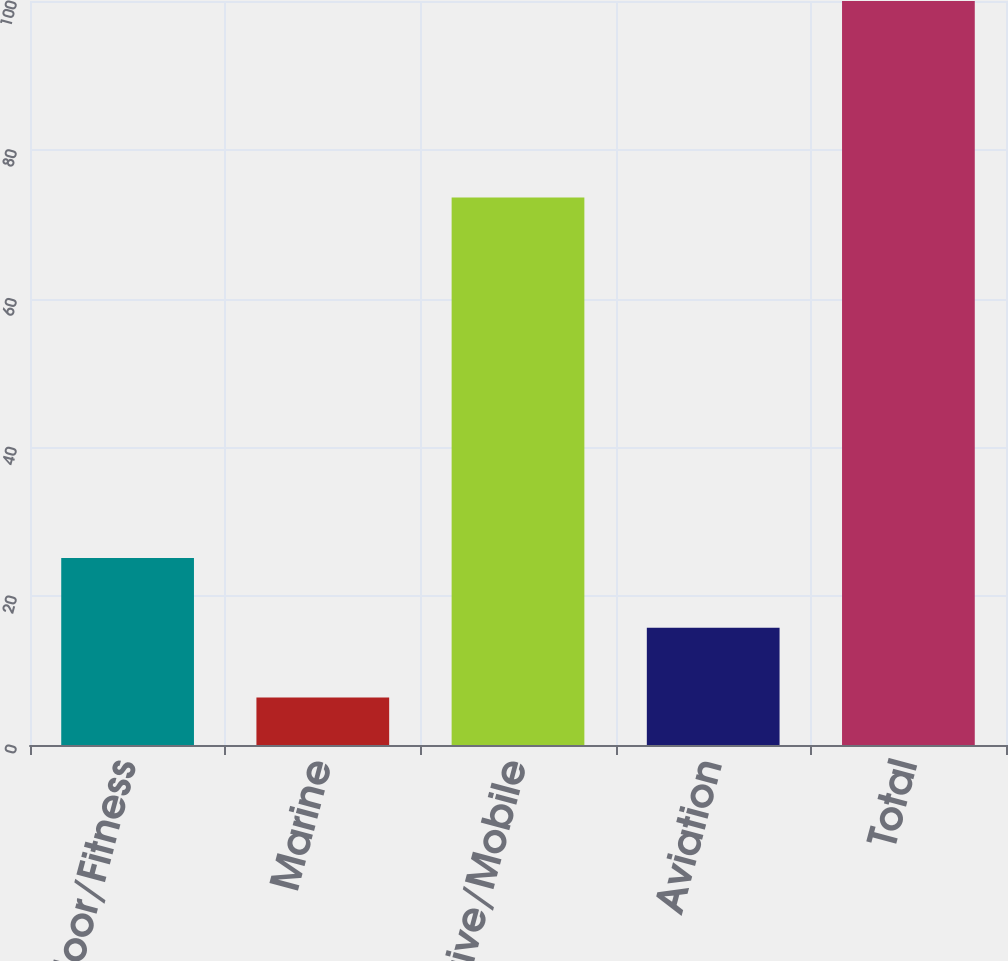Convert chart to OTSL. <chart><loc_0><loc_0><loc_500><loc_500><bar_chart><fcel>Outdoor/Fitness<fcel>Marine<fcel>Automotive/Mobile<fcel>Aviation<fcel>Total<nl><fcel>25.12<fcel>6.4<fcel>73.6<fcel>15.76<fcel>100<nl></chart> 